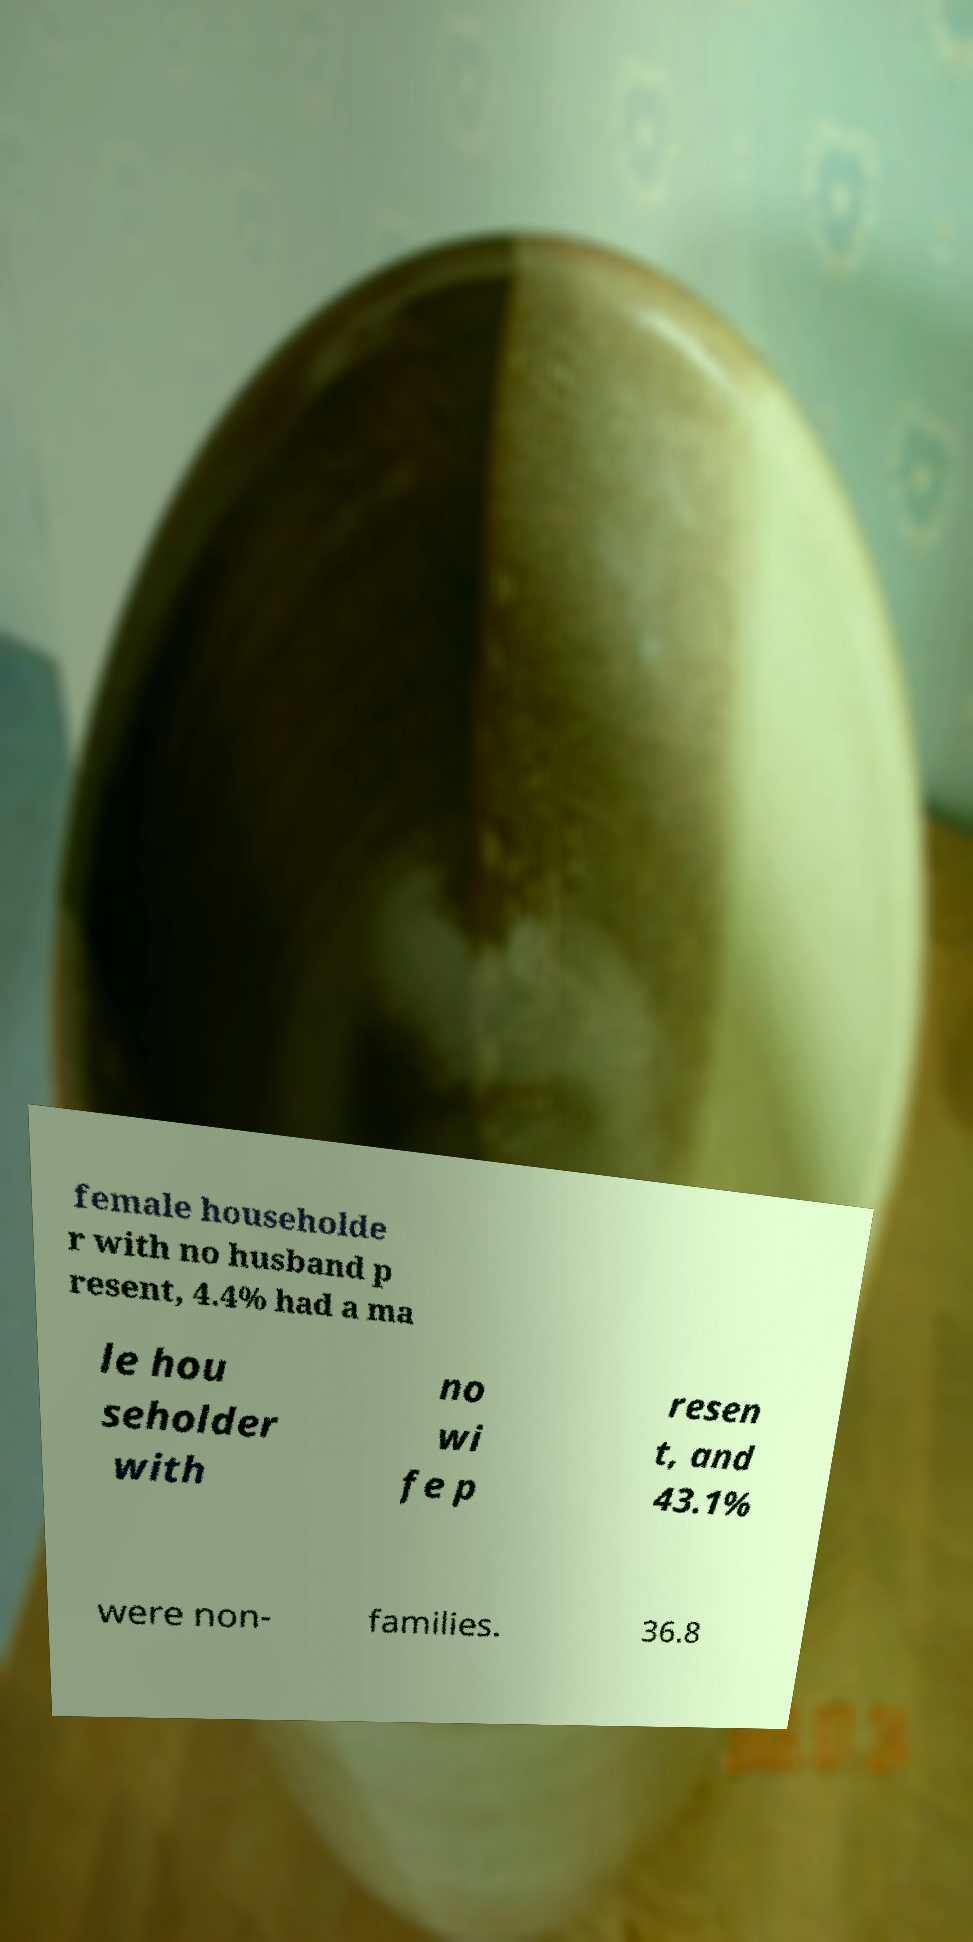Could you extract and type out the text from this image? female householde r with no husband p resent, 4.4% had a ma le hou seholder with no wi fe p resen t, and 43.1% were non- families. 36.8 